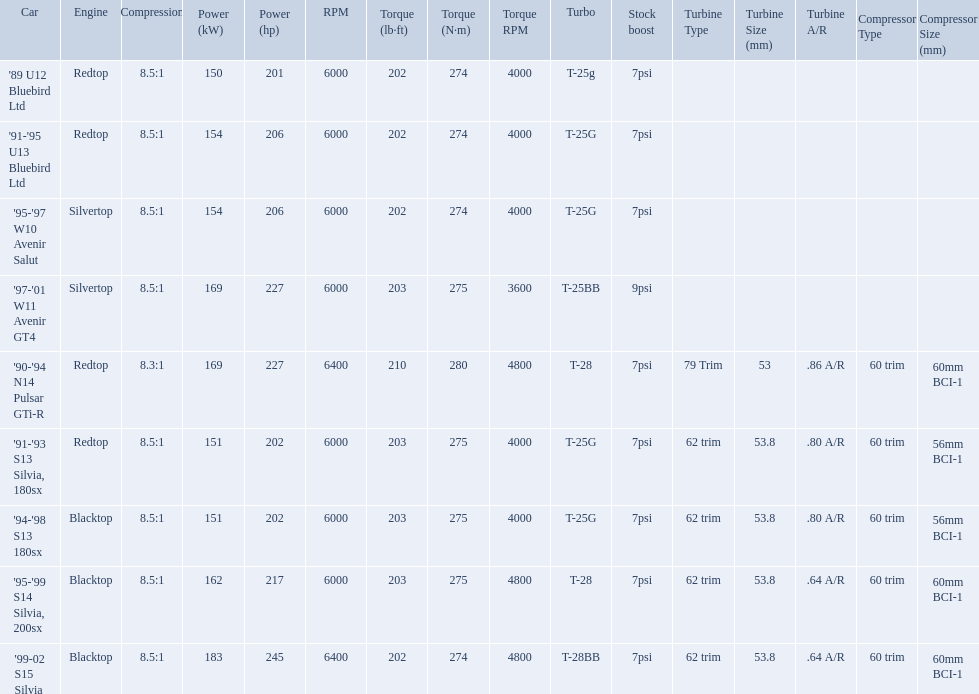What are all of the cars? '89 U12 Bluebird Ltd, '91-'95 U13 Bluebird Ltd, '95-'97 W10 Avenir Salut, '97-'01 W11 Avenir GT4, '90-'94 N14 Pulsar GTi-R, '91-'93 S13 Silvia, 180sx, '94-'98 S13 180sx, '95-'99 S14 Silvia, 200sx, '99-02 S15 Silvia. What is their rated power? 150 kW (201 hp) @ 6000 rpm, 154 kW (206 hp) @ 6000 rpm, 154 kW (206 hp) @ 6000 rpm, 169 kW (227 hp) @ 6000 rpm, 169 kW (227 hp) @ 6400 rpm (Euro: 164 kW (220 hp) @ 6400 rpm), 151 kW (202 hp) @ 6000 rpm, 151 kW (202 hp) @ 6000 rpm, 162 kW (217 hp) @ 6000 rpm, 183 kW (245 hp) @ 6400 rpm. Which car has the most power? '99-02 S15 Silvia. Which cars list turbine details? '90-'94 N14 Pulsar GTi-R, '91-'93 S13 Silvia, 180sx, '94-'98 S13 180sx, '95-'99 S14 Silvia, 200sx, '99-02 S15 Silvia. Which of these hit their peak hp at the highest rpm? '90-'94 N14 Pulsar GTi-R, '99-02 S15 Silvia. Of those what is the compression of the only engine that isn't blacktop?? 8.3:1. What are all of the nissan cars? '89 U12 Bluebird Ltd, '91-'95 U13 Bluebird Ltd, '95-'97 W10 Avenir Salut, '97-'01 W11 Avenir GT4, '90-'94 N14 Pulsar GTi-R, '91-'93 S13 Silvia, 180sx, '94-'98 S13 180sx, '95-'99 S14 Silvia, 200sx, '99-02 S15 Silvia. Of these cars, which one is a '90-'94 n14 pulsar gti-r? '90-'94 N14 Pulsar GTi-R. What is the compression of this car? 8.3:1. 